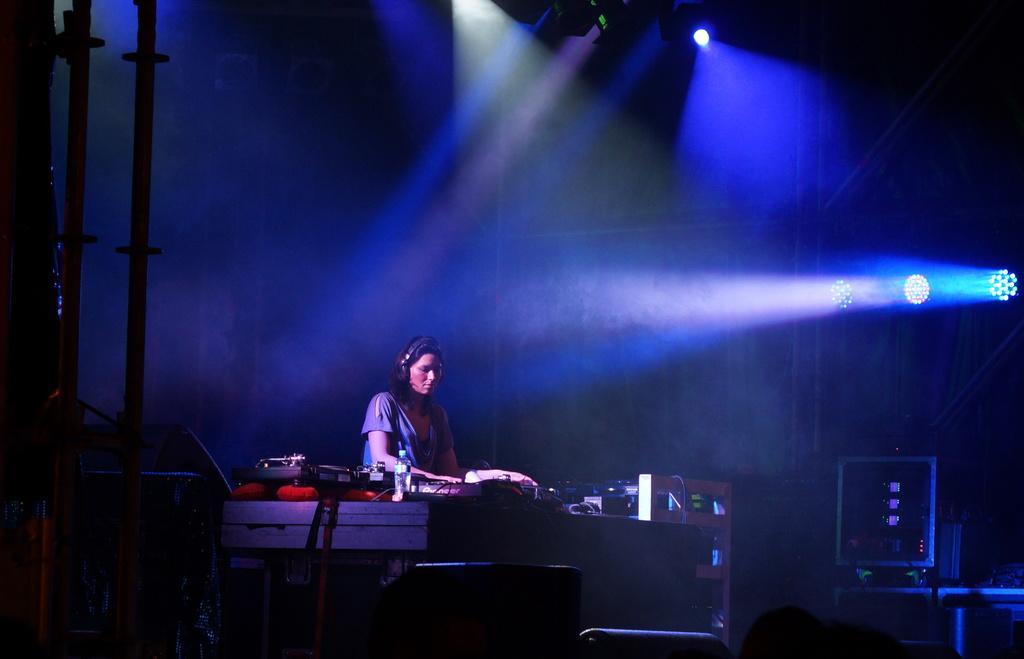Can you describe this image briefly? In this image I see a woman over here and I see few equipment over here and I see the rods over here. In the background I see the lights over here and it is a bit dark. 